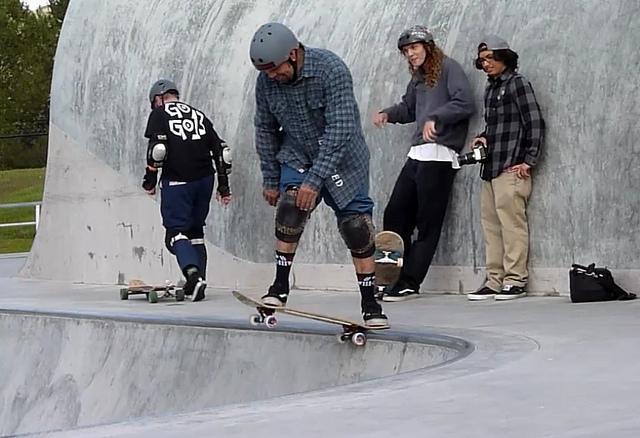Besides his head what part of his body is the skateboarder on the edge of the ramp protecting?
Choose the right answer and clarify with the format: 'Answer: answer
Rationale: rationale.'
Options: Shoulders, wrists, knees, elbows. Answer: knees.
Rationale: The person is wearing kneepads. 